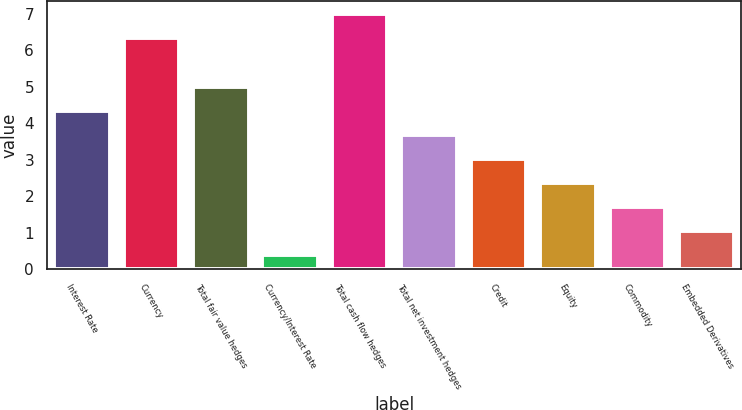Convert chart to OTSL. <chart><loc_0><loc_0><loc_500><loc_500><bar_chart><fcel>Interest Rate<fcel>Currency<fcel>Total fair value hedges<fcel>Currency/Interest Rate<fcel>Total cash flow hedges<fcel>Total net investment hedges<fcel>Credit<fcel>Equity<fcel>Commodity<fcel>Embedded Derivatives<nl><fcel>4.34<fcel>6.32<fcel>5<fcel>0.38<fcel>7<fcel>3.68<fcel>3.02<fcel>2.36<fcel>1.7<fcel>1.04<nl></chart> 